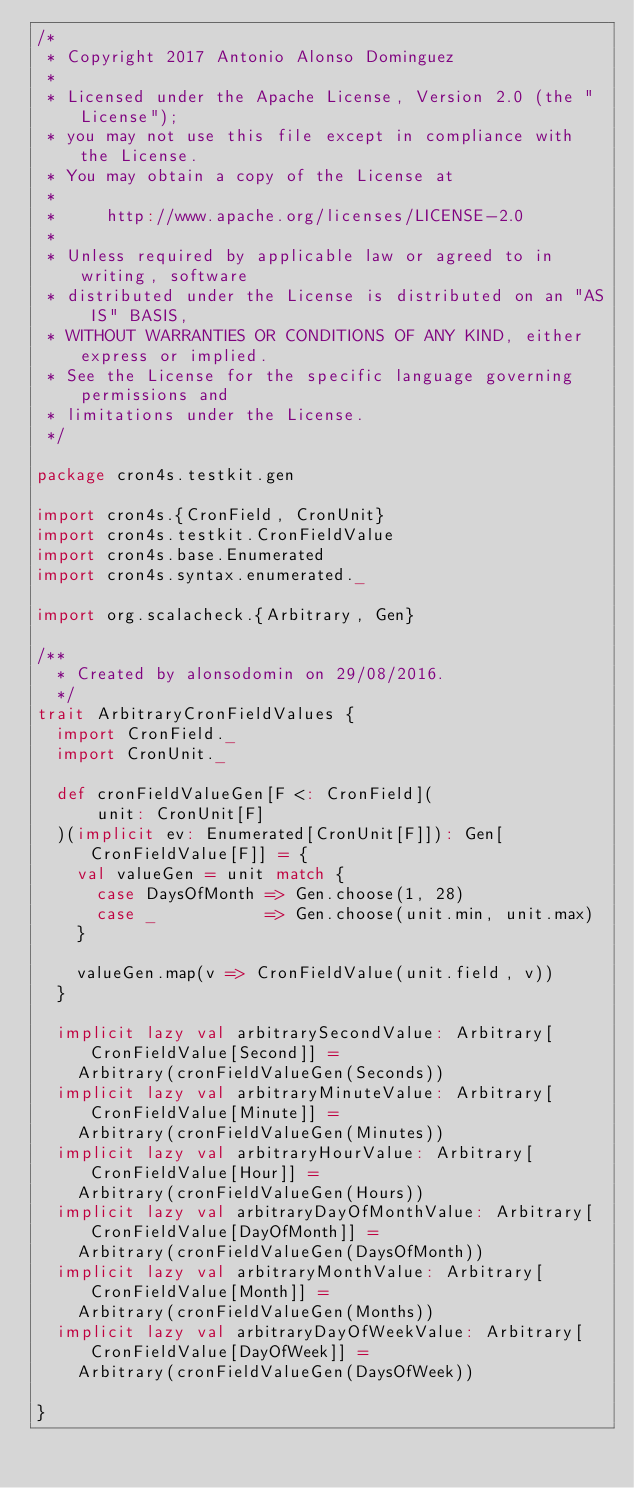<code> <loc_0><loc_0><loc_500><loc_500><_Scala_>/*
 * Copyright 2017 Antonio Alonso Dominguez
 *
 * Licensed under the Apache License, Version 2.0 (the "License");
 * you may not use this file except in compliance with the License.
 * You may obtain a copy of the License at
 *
 *     http://www.apache.org/licenses/LICENSE-2.0
 *
 * Unless required by applicable law or agreed to in writing, software
 * distributed under the License is distributed on an "AS IS" BASIS,
 * WITHOUT WARRANTIES OR CONDITIONS OF ANY KIND, either express or implied.
 * See the License for the specific language governing permissions and
 * limitations under the License.
 */

package cron4s.testkit.gen

import cron4s.{CronField, CronUnit}
import cron4s.testkit.CronFieldValue
import cron4s.base.Enumerated
import cron4s.syntax.enumerated._

import org.scalacheck.{Arbitrary, Gen}

/**
  * Created by alonsodomin on 29/08/2016.
  */
trait ArbitraryCronFieldValues {
  import CronField._
  import CronUnit._

  def cronFieldValueGen[F <: CronField](
      unit: CronUnit[F]
  )(implicit ev: Enumerated[CronUnit[F]]): Gen[CronFieldValue[F]] = {
    val valueGen = unit match {
      case DaysOfMonth => Gen.choose(1, 28)
      case _           => Gen.choose(unit.min, unit.max)
    }

    valueGen.map(v => CronFieldValue(unit.field, v))
  }

  implicit lazy val arbitrarySecondValue: Arbitrary[CronFieldValue[Second]] =
    Arbitrary(cronFieldValueGen(Seconds))
  implicit lazy val arbitraryMinuteValue: Arbitrary[CronFieldValue[Minute]] =
    Arbitrary(cronFieldValueGen(Minutes))
  implicit lazy val arbitraryHourValue: Arbitrary[CronFieldValue[Hour]] =
    Arbitrary(cronFieldValueGen(Hours))
  implicit lazy val arbitraryDayOfMonthValue: Arbitrary[CronFieldValue[DayOfMonth]] =
    Arbitrary(cronFieldValueGen(DaysOfMonth))
  implicit lazy val arbitraryMonthValue: Arbitrary[CronFieldValue[Month]] =
    Arbitrary(cronFieldValueGen(Months))
  implicit lazy val arbitraryDayOfWeekValue: Arbitrary[CronFieldValue[DayOfWeek]] =
    Arbitrary(cronFieldValueGen(DaysOfWeek))

}
</code> 